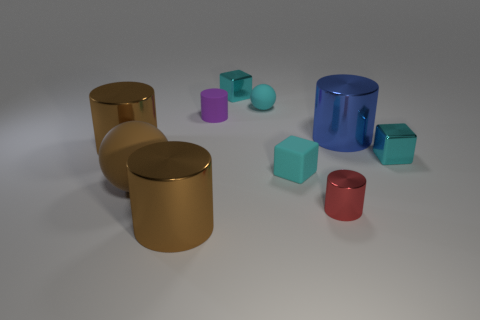Is there another large metal thing that has the same shape as the large blue metal thing?
Keep it short and to the point. Yes. There is a small shiny thing that is left of the rubber block; is there a large thing that is on the left side of it?
Ensure brevity in your answer.  Yes. What number of blue things have the same material as the purple thing?
Your response must be concise. 0. Is there a blue block?
Ensure brevity in your answer.  No. What number of big metallic cylinders have the same color as the large rubber ball?
Give a very brief answer. 2. Does the blue cylinder have the same material as the big cylinder in front of the big ball?
Offer a terse response. Yes. Are there more big metal objects that are on the left side of the brown ball than green metallic cubes?
Provide a short and direct response. Yes. There is a tiny ball; does it have the same color as the metal cube in front of the small purple rubber cylinder?
Ensure brevity in your answer.  Yes. Are there an equal number of cyan things left of the matte cylinder and cyan matte objects on the right side of the small metallic cylinder?
Your answer should be very brief. Yes. There is a brown cylinder in front of the rubber block; what is its material?
Provide a succinct answer. Metal. 